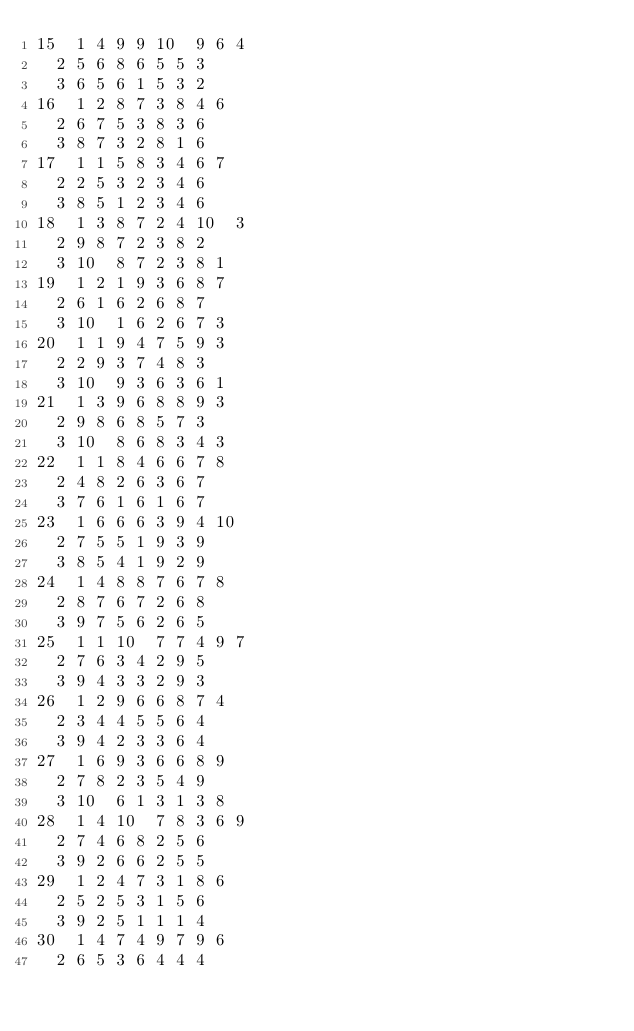Convert code to text. <code><loc_0><loc_0><loc_500><loc_500><_ObjectiveC_>15	1	4	9	9	10	9	6	4	
	2	5	6	8	6	5	5	3	
	3	6	5	6	1	5	3	2	
16	1	2	8	7	3	8	4	6	
	2	6	7	5	3	8	3	6	
	3	8	7	3	2	8	1	6	
17	1	1	5	8	3	4	6	7	
	2	2	5	3	2	3	4	6	
	3	8	5	1	2	3	4	6	
18	1	3	8	7	2	4	10	3	
	2	9	8	7	2	3	8	2	
	3	10	8	7	2	3	8	1	
19	1	2	1	9	3	6	8	7	
	2	6	1	6	2	6	8	7	
	3	10	1	6	2	6	7	3	
20	1	1	9	4	7	5	9	3	
	2	2	9	3	7	4	8	3	
	3	10	9	3	6	3	6	1	
21	1	3	9	6	8	8	9	3	
	2	9	8	6	8	5	7	3	
	3	10	8	6	8	3	4	3	
22	1	1	8	4	6	6	7	8	
	2	4	8	2	6	3	6	7	
	3	7	6	1	6	1	6	7	
23	1	6	6	6	3	9	4	10	
	2	7	5	5	1	9	3	9	
	3	8	5	4	1	9	2	9	
24	1	4	8	8	7	6	7	8	
	2	8	7	6	7	2	6	8	
	3	9	7	5	6	2	6	5	
25	1	1	10	7	7	4	9	7	
	2	7	6	3	4	2	9	5	
	3	9	4	3	3	2	9	3	
26	1	2	9	6	6	8	7	4	
	2	3	4	4	5	5	6	4	
	3	9	4	2	3	3	6	4	
27	1	6	9	3	6	6	8	9	
	2	7	8	2	3	5	4	9	
	3	10	6	1	3	1	3	8	
28	1	4	10	7	8	3	6	9	
	2	7	4	6	8	2	5	6	
	3	9	2	6	6	2	5	5	
29	1	2	4	7	3	1	8	6	
	2	5	2	5	3	1	5	6	
	3	9	2	5	1	1	1	4	
30	1	4	7	4	9	7	9	6	
	2	6	5	3	6	4	4	4	</code> 